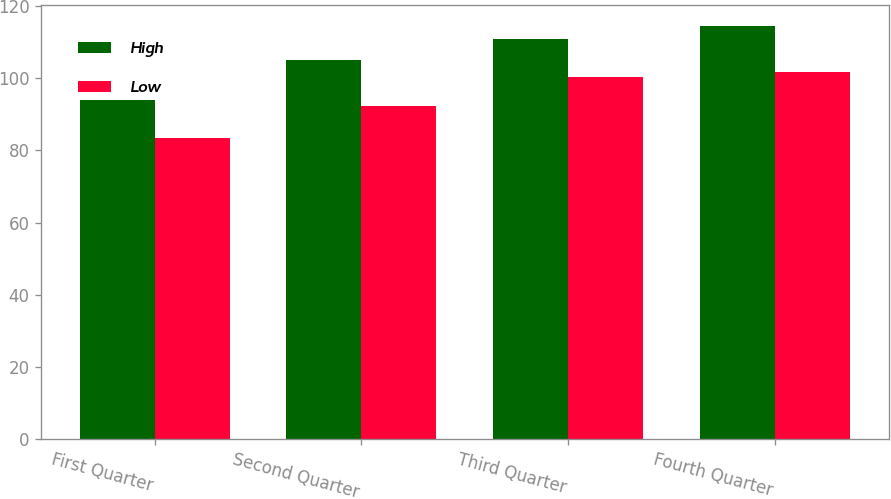Convert chart. <chart><loc_0><loc_0><loc_500><loc_500><stacked_bar_chart><ecel><fcel>First Quarter<fcel>Second Quarter<fcel>Third Quarter<fcel>Fourth Quarter<nl><fcel>High<fcel>93.87<fcel>105.13<fcel>110.89<fcel>114.6<nl><fcel>Low<fcel>83.35<fcel>92.45<fcel>100.3<fcel>101.72<nl></chart> 